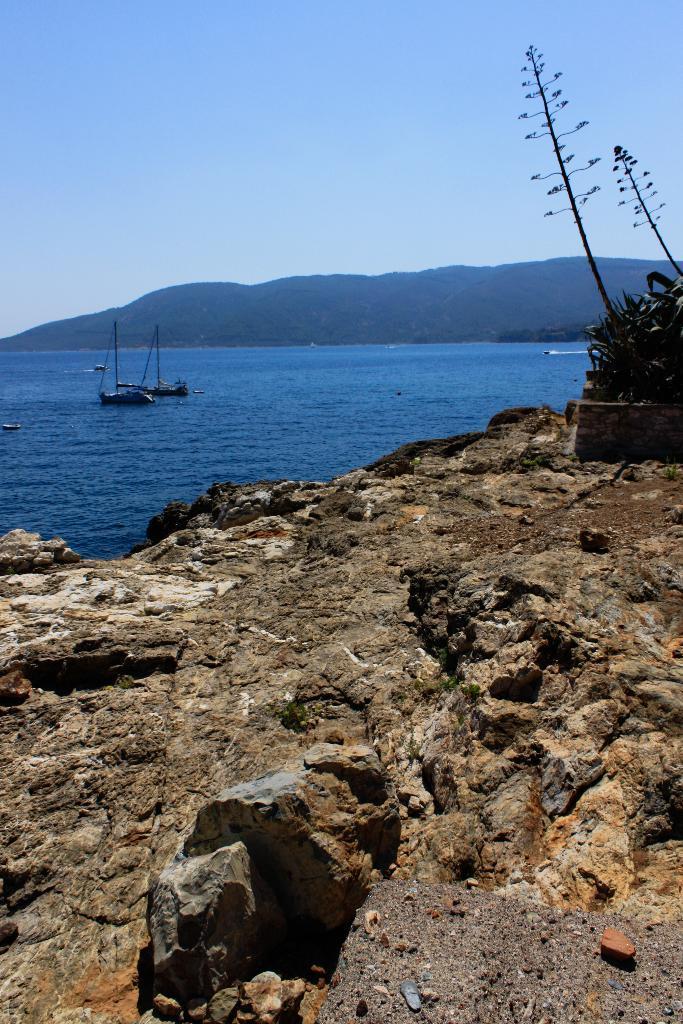Can you describe this image briefly? In the foreground of this image, there is rock and few plants on the right. In the background, there are few boats on the water, a mountain and the sky. 